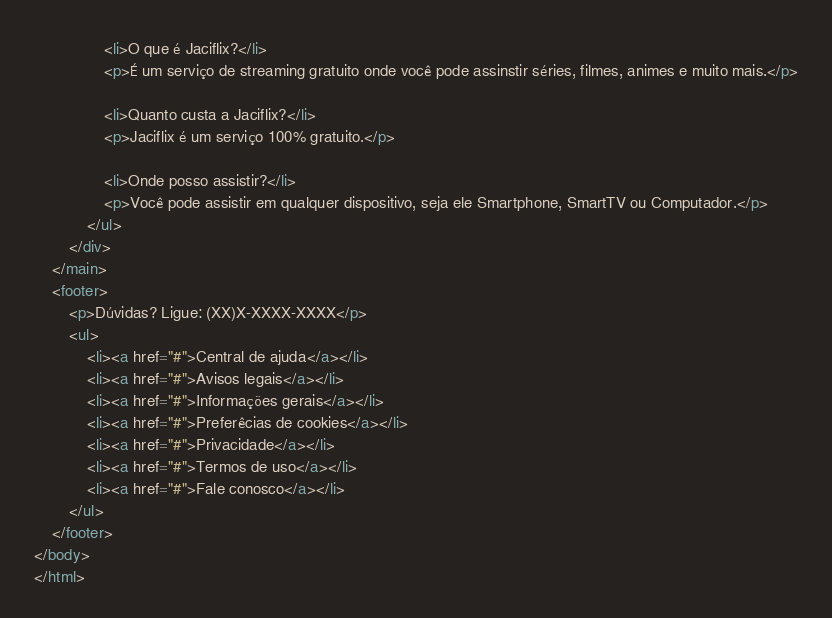<code> <loc_0><loc_0><loc_500><loc_500><_HTML_>                <li>O que é Jaciflix?</li>
                <p>É um serviço de streaming gratuito onde você pode assinstir séries, filmes, animes e muito mais.</p>

                <li>Quanto custa a Jaciflix?</li>
                <p>Jaciflix é um serviço 100% gratuito.</p>

                <li>Onde posso assistir?</li>
                <p>Você pode assistir em qualquer dispositivo, seja ele Smartphone, SmartTV ou Computador.</p>
            </ul>
        </div>
    </main>
    <footer>
        <p>Dúvidas? Ligue: (XX)X-XXXX-XXXX</p>
        <ul>
            <li><a href="#">Central de ajuda</a></li>
            <li><a href="#">Avisos legais</a></li>
            <li><a href="#">Informações gerais</a></li>
            <li><a href="#">Preferêcias de cookies</a></li>
            <li><a href="#">Privacidade</a></li>
            <li><a href="#">Termos de uso</a></li>
            <li><a href="#">Fale conosco</a></li>
        </ul>
    </footer>
</body>
</html></code> 